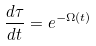Convert formula to latex. <formula><loc_0><loc_0><loc_500><loc_500>\frac { d \tau } { d t } = e ^ { - \Omega ( t ) }</formula> 